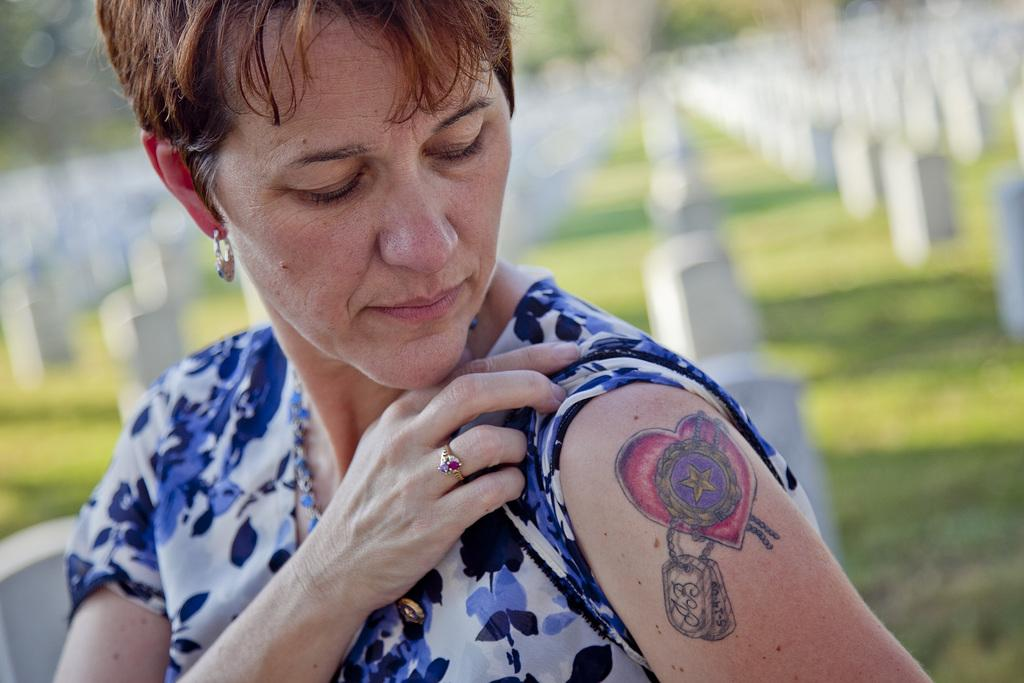What is the main subject of the image? There is a person in the image. Can you describe the background of the image? The background of the image is blurred. What distinguishing feature can be seen on the person's hand? The person has a tattoo on their hand. What type of education does the person in the image have? There is no information about the person's education in the image. What statement is the person making in the image? There is no statement being made by the person in the image. 